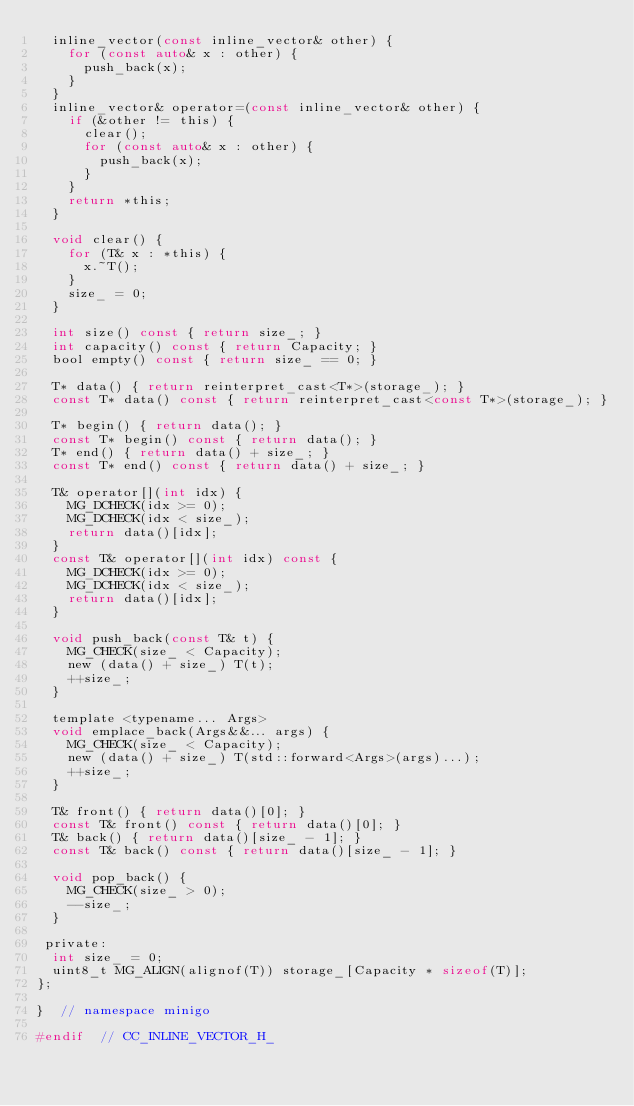<code> <loc_0><loc_0><loc_500><loc_500><_C_>  inline_vector(const inline_vector& other) {
    for (const auto& x : other) {
      push_back(x);
    }
  }
  inline_vector& operator=(const inline_vector& other) {
    if (&other != this) {
      clear();
      for (const auto& x : other) {
        push_back(x);
      }
    }
    return *this;
  }

  void clear() {
    for (T& x : *this) {
      x.~T();
    }
    size_ = 0;
  }

  int size() const { return size_; }
  int capacity() const { return Capacity; }
  bool empty() const { return size_ == 0; }

  T* data() { return reinterpret_cast<T*>(storage_); }
  const T* data() const { return reinterpret_cast<const T*>(storage_); }

  T* begin() { return data(); }
  const T* begin() const { return data(); }
  T* end() { return data() + size_; }
  const T* end() const { return data() + size_; }

  T& operator[](int idx) {
    MG_DCHECK(idx >= 0);
    MG_DCHECK(idx < size_);
    return data()[idx];
  }
  const T& operator[](int idx) const {
    MG_DCHECK(idx >= 0);
    MG_DCHECK(idx < size_);
    return data()[idx];
  }

  void push_back(const T& t) {
    MG_CHECK(size_ < Capacity);
    new (data() + size_) T(t);
    ++size_;
  }

  template <typename... Args>
  void emplace_back(Args&&... args) {
    MG_CHECK(size_ < Capacity);
    new (data() + size_) T(std::forward<Args>(args)...);
    ++size_;
  }

  T& front() { return data()[0]; }
  const T& front() const { return data()[0]; }
  T& back() { return data()[size_ - 1]; }
  const T& back() const { return data()[size_ - 1]; }

  void pop_back() {
    MG_CHECK(size_ > 0);
    --size_;
  }

 private:
  int size_ = 0;
  uint8_t MG_ALIGN(alignof(T)) storage_[Capacity * sizeof(T)];
};

}  // namespace minigo

#endif  // CC_INLINE_VECTOR_H_
</code> 